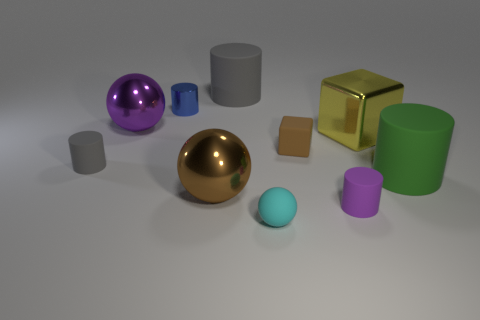How many metallic objects have the same color as the small block?
Your answer should be very brief. 1. What is the size of the green object that is the same material as the small sphere?
Offer a very short reply. Large. What number of things are either cyan metallic blocks or small cylinders?
Provide a succinct answer. 3. The metallic cylinder that is behind the small ball is what color?
Ensure brevity in your answer.  Blue. There is a green matte thing that is the same shape as the large gray thing; what size is it?
Your answer should be very brief. Large. How many things are either tiny objects that are behind the rubber block or big cylinders on the left side of the big block?
Your response must be concise. 2. There is a object that is both in front of the big cube and to the left of the small shiny cylinder; what size is it?
Offer a very short reply. Small. There is a small brown object; does it have the same shape as the large yellow metal object to the right of the small gray thing?
Provide a succinct answer. Yes. What number of objects are either big metallic spheres behind the tiny gray matte thing or green balls?
Give a very brief answer. 1. Is the large block made of the same material as the brown thing to the right of the rubber sphere?
Offer a terse response. No. 